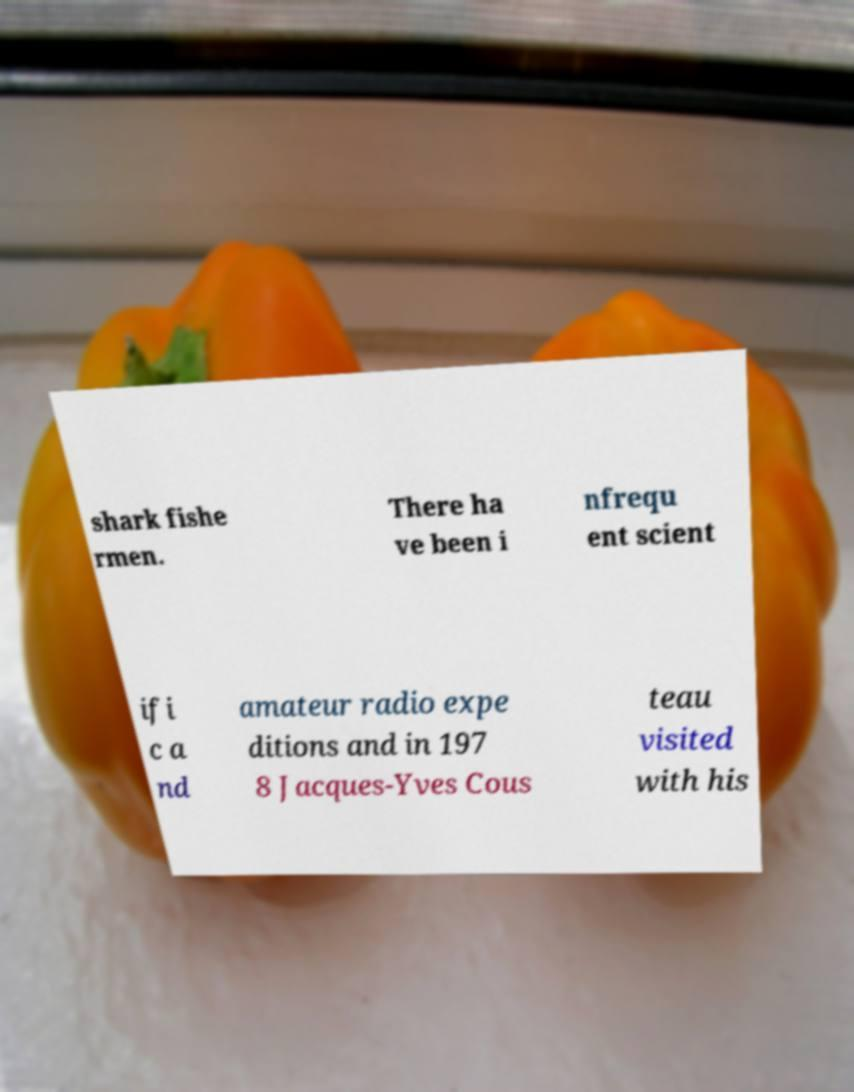Can you read and provide the text displayed in the image?This photo seems to have some interesting text. Can you extract and type it out for me? shark fishe rmen. There ha ve been i nfrequ ent scient ifi c a nd amateur radio expe ditions and in 197 8 Jacques-Yves Cous teau visited with his 